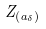Convert formula to latex. <formula><loc_0><loc_0><loc_500><loc_500>Z _ { ( a _ { \delta } ) }</formula> 